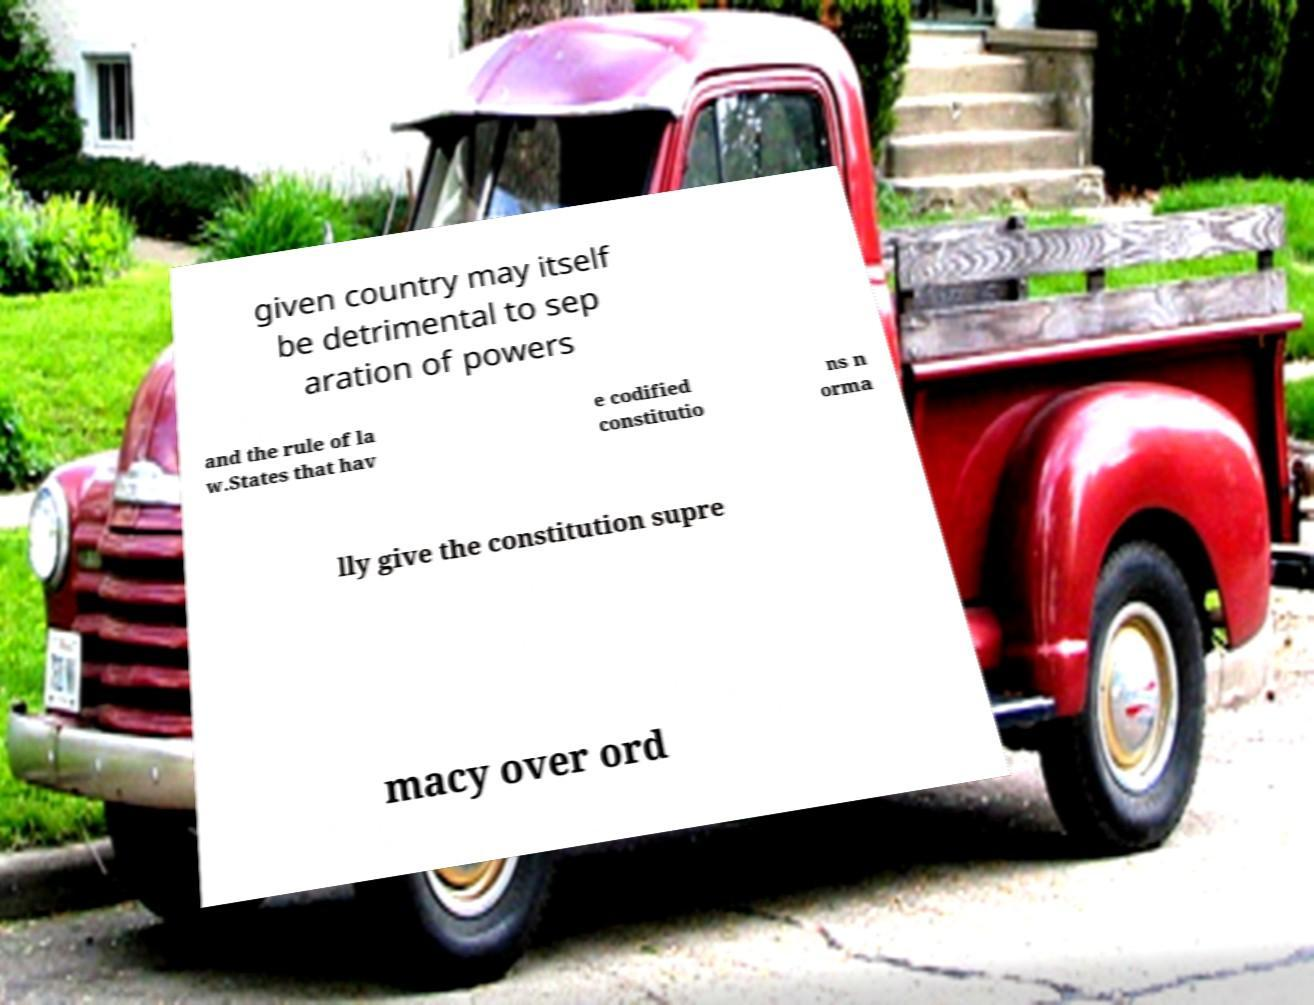I need the written content from this picture converted into text. Can you do that? given country may itself be detrimental to sep aration of powers and the rule of la w.States that hav e codified constitutio ns n orma lly give the constitution supre macy over ord 